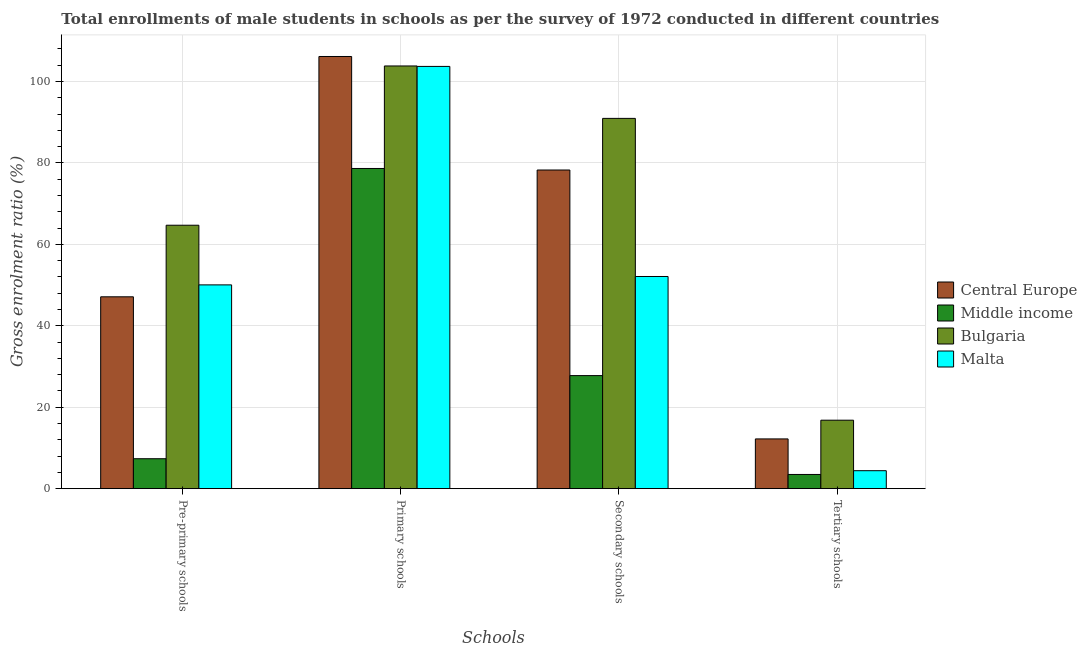How many different coloured bars are there?
Make the answer very short. 4. How many groups of bars are there?
Provide a succinct answer. 4. Are the number of bars on each tick of the X-axis equal?
Provide a succinct answer. Yes. How many bars are there on the 1st tick from the right?
Your response must be concise. 4. What is the label of the 4th group of bars from the left?
Offer a very short reply. Tertiary schools. What is the gross enrolment ratio(male) in secondary schools in Bulgaria?
Ensure brevity in your answer.  90.93. Across all countries, what is the maximum gross enrolment ratio(male) in secondary schools?
Provide a succinct answer. 90.93. Across all countries, what is the minimum gross enrolment ratio(male) in secondary schools?
Offer a terse response. 27.77. In which country was the gross enrolment ratio(male) in secondary schools maximum?
Your response must be concise. Bulgaria. What is the total gross enrolment ratio(male) in tertiary schools in the graph?
Ensure brevity in your answer.  36.94. What is the difference between the gross enrolment ratio(male) in secondary schools in Bulgaria and that in Central Europe?
Your answer should be very brief. 12.68. What is the difference between the gross enrolment ratio(male) in primary schools in Bulgaria and the gross enrolment ratio(male) in pre-primary schools in Middle income?
Give a very brief answer. 96.44. What is the average gross enrolment ratio(male) in primary schools per country?
Provide a short and direct response. 98.06. What is the difference between the gross enrolment ratio(male) in secondary schools and gross enrolment ratio(male) in primary schools in Central Europe?
Offer a very short reply. -27.88. What is the ratio of the gross enrolment ratio(male) in secondary schools in Bulgaria to that in Central Europe?
Give a very brief answer. 1.16. Is the difference between the gross enrolment ratio(male) in tertiary schools in Bulgaria and Central Europe greater than the difference between the gross enrolment ratio(male) in secondary schools in Bulgaria and Central Europe?
Provide a short and direct response. No. What is the difference between the highest and the second highest gross enrolment ratio(male) in pre-primary schools?
Your answer should be very brief. 14.65. What is the difference between the highest and the lowest gross enrolment ratio(male) in pre-primary schools?
Provide a short and direct response. 57.33. In how many countries, is the gross enrolment ratio(male) in tertiary schools greater than the average gross enrolment ratio(male) in tertiary schools taken over all countries?
Make the answer very short. 2. Is the sum of the gross enrolment ratio(male) in secondary schools in Bulgaria and Central Europe greater than the maximum gross enrolment ratio(male) in primary schools across all countries?
Ensure brevity in your answer.  Yes. Is it the case that in every country, the sum of the gross enrolment ratio(male) in pre-primary schools and gross enrolment ratio(male) in secondary schools is greater than the sum of gross enrolment ratio(male) in tertiary schools and gross enrolment ratio(male) in primary schools?
Your answer should be compact. No. What does the 2nd bar from the left in Secondary schools represents?
Provide a succinct answer. Middle income. What does the 4th bar from the right in Secondary schools represents?
Offer a very short reply. Central Europe. Is it the case that in every country, the sum of the gross enrolment ratio(male) in pre-primary schools and gross enrolment ratio(male) in primary schools is greater than the gross enrolment ratio(male) in secondary schools?
Make the answer very short. Yes. Does the graph contain any zero values?
Keep it short and to the point. No. Does the graph contain grids?
Offer a very short reply. Yes. Where does the legend appear in the graph?
Your answer should be compact. Center right. What is the title of the graph?
Your response must be concise. Total enrollments of male students in schools as per the survey of 1972 conducted in different countries. What is the label or title of the X-axis?
Ensure brevity in your answer.  Schools. What is the Gross enrolment ratio (%) of Central Europe in Pre-primary schools?
Offer a very short reply. 47.12. What is the Gross enrolment ratio (%) in Middle income in Pre-primary schools?
Make the answer very short. 7.36. What is the Gross enrolment ratio (%) of Bulgaria in Pre-primary schools?
Offer a terse response. 64.69. What is the Gross enrolment ratio (%) in Malta in Pre-primary schools?
Your answer should be very brief. 50.04. What is the Gross enrolment ratio (%) of Central Europe in Primary schools?
Provide a short and direct response. 106.13. What is the Gross enrolment ratio (%) of Middle income in Primary schools?
Make the answer very short. 78.63. What is the Gross enrolment ratio (%) of Bulgaria in Primary schools?
Your answer should be compact. 103.8. What is the Gross enrolment ratio (%) of Malta in Primary schools?
Ensure brevity in your answer.  103.69. What is the Gross enrolment ratio (%) of Central Europe in Secondary schools?
Keep it short and to the point. 78.25. What is the Gross enrolment ratio (%) of Middle income in Secondary schools?
Your answer should be compact. 27.77. What is the Gross enrolment ratio (%) in Bulgaria in Secondary schools?
Keep it short and to the point. 90.93. What is the Gross enrolment ratio (%) in Malta in Secondary schools?
Provide a short and direct response. 52.1. What is the Gross enrolment ratio (%) in Central Europe in Tertiary schools?
Give a very brief answer. 12.22. What is the Gross enrolment ratio (%) of Middle income in Tertiary schools?
Ensure brevity in your answer.  3.49. What is the Gross enrolment ratio (%) of Bulgaria in Tertiary schools?
Offer a terse response. 16.82. What is the Gross enrolment ratio (%) in Malta in Tertiary schools?
Give a very brief answer. 4.42. Across all Schools, what is the maximum Gross enrolment ratio (%) in Central Europe?
Your response must be concise. 106.13. Across all Schools, what is the maximum Gross enrolment ratio (%) of Middle income?
Your answer should be compact. 78.63. Across all Schools, what is the maximum Gross enrolment ratio (%) in Bulgaria?
Provide a succinct answer. 103.8. Across all Schools, what is the maximum Gross enrolment ratio (%) in Malta?
Your response must be concise. 103.69. Across all Schools, what is the minimum Gross enrolment ratio (%) in Central Europe?
Offer a very short reply. 12.22. Across all Schools, what is the minimum Gross enrolment ratio (%) in Middle income?
Make the answer very short. 3.49. Across all Schools, what is the minimum Gross enrolment ratio (%) of Bulgaria?
Your answer should be compact. 16.82. Across all Schools, what is the minimum Gross enrolment ratio (%) in Malta?
Your response must be concise. 4.42. What is the total Gross enrolment ratio (%) of Central Europe in the graph?
Provide a short and direct response. 243.71. What is the total Gross enrolment ratio (%) in Middle income in the graph?
Provide a succinct answer. 117.24. What is the total Gross enrolment ratio (%) in Bulgaria in the graph?
Your answer should be very brief. 276.23. What is the total Gross enrolment ratio (%) of Malta in the graph?
Provide a succinct answer. 210.25. What is the difference between the Gross enrolment ratio (%) of Central Europe in Pre-primary schools and that in Primary schools?
Make the answer very short. -59.01. What is the difference between the Gross enrolment ratio (%) of Middle income in Pre-primary schools and that in Primary schools?
Offer a very short reply. -71.27. What is the difference between the Gross enrolment ratio (%) of Bulgaria in Pre-primary schools and that in Primary schools?
Provide a short and direct response. -39.11. What is the difference between the Gross enrolment ratio (%) of Malta in Pre-primary schools and that in Primary schools?
Your response must be concise. -53.65. What is the difference between the Gross enrolment ratio (%) of Central Europe in Pre-primary schools and that in Secondary schools?
Offer a very short reply. -31.13. What is the difference between the Gross enrolment ratio (%) in Middle income in Pre-primary schools and that in Secondary schools?
Give a very brief answer. -20.41. What is the difference between the Gross enrolment ratio (%) in Bulgaria in Pre-primary schools and that in Secondary schools?
Offer a very short reply. -26.24. What is the difference between the Gross enrolment ratio (%) of Malta in Pre-primary schools and that in Secondary schools?
Make the answer very short. -2.06. What is the difference between the Gross enrolment ratio (%) in Central Europe in Pre-primary schools and that in Tertiary schools?
Ensure brevity in your answer.  34.9. What is the difference between the Gross enrolment ratio (%) in Middle income in Pre-primary schools and that in Tertiary schools?
Offer a very short reply. 3.87. What is the difference between the Gross enrolment ratio (%) of Bulgaria in Pre-primary schools and that in Tertiary schools?
Your answer should be very brief. 47.87. What is the difference between the Gross enrolment ratio (%) of Malta in Pre-primary schools and that in Tertiary schools?
Your response must be concise. 45.63. What is the difference between the Gross enrolment ratio (%) in Central Europe in Primary schools and that in Secondary schools?
Offer a very short reply. 27.88. What is the difference between the Gross enrolment ratio (%) of Middle income in Primary schools and that in Secondary schools?
Provide a succinct answer. 50.86. What is the difference between the Gross enrolment ratio (%) of Bulgaria in Primary schools and that in Secondary schools?
Your answer should be very brief. 12.87. What is the difference between the Gross enrolment ratio (%) of Malta in Primary schools and that in Secondary schools?
Ensure brevity in your answer.  51.58. What is the difference between the Gross enrolment ratio (%) of Central Europe in Primary schools and that in Tertiary schools?
Provide a succinct answer. 93.91. What is the difference between the Gross enrolment ratio (%) in Middle income in Primary schools and that in Tertiary schools?
Your response must be concise. 75.14. What is the difference between the Gross enrolment ratio (%) of Bulgaria in Primary schools and that in Tertiary schools?
Make the answer very short. 86.98. What is the difference between the Gross enrolment ratio (%) of Malta in Primary schools and that in Tertiary schools?
Provide a succinct answer. 99.27. What is the difference between the Gross enrolment ratio (%) in Central Europe in Secondary schools and that in Tertiary schools?
Provide a succinct answer. 66.03. What is the difference between the Gross enrolment ratio (%) of Middle income in Secondary schools and that in Tertiary schools?
Ensure brevity in your answer.  24.28. What is the difference between the Gross enrolment ratio (%) in Bulgaria in Secondary schools and that in Tertiary schools?
Your response must be concise. 74.11. What is the difference between the Gross enrolment ratio (%) in Malta in Secondary schools and that in Tertiary schools?
Offer a terse response. 47.69. What is the difference between the Gross enrolment ratio (%) of Central Europe in Pre-primary schools and the Gross enrolment ratio (%) of Middle income in Primary schools?
Give a very brief answer. -31.51. What is the difference between the Gross enrolment ratio (%) in Central Europe in Pre-primary schools and the Gross enrolment ratio (%) in Bulgaria in Primary schools?
Offer a terse response. -56.68. What is the difference between the Gross enrolment ratio (%) of Central Europe in Pre-primary schools and the Gross enrolment ratio (%) of Malta in Primary schools?
Your answer should be very brief. -56.57. What is the difference between the Gross enrolment ratio (%) in Middle income in Pre-primary schools and the Gross enrolment ratio (%) in Bulgaria in Primary schools?
Make the answer very short. -96.44. What is the difference between the Gross enrolment ratio (%) in Middle income in Pre-primary schools and the Gross enrolment ratio (%) in Malta in Primary schools?
Keep it short and to the point. -96.33. What is the difference between the Gross enrolment ratio (%) of Bulgaria in Pre-primary schools and the Gross enrolment ratio (%) of Malta in Primary schools?
Make the answer very short. -39. What is the difference between the Gross enrolment ratio (%) of Central Europe in Pre-primary schools and the Gross enrolment ratio (%) of Middle income in Secondary schools?
Your answer should be compact. 19.35. What is the difference between the Gross enrolment ratio (%) in Central Europe in Pre-primary schools and the Gross enrolment ratio (%) in Bulgaria in Secondary schools?
Keep it short and to the point. -43.81. What is the difference between the Gross enrolment ratio (%) in Central Europe in Pre-primary schools and the Gross enrolment ratio (%) in Malta in Secondary schools?
Give a very brief answer. -4.99. What is the difference between the Gross enrolment ratio (%) of Middle income in Pre-primary schools and the Gross enrolment ratio (%) of Bulgaria in Secondary schools?
Offer a terse response. -83.57. What is the difference between the Gross enrolment ratio (%) of Middle income in Pre-primary schools and the Gross enrolment ratio (%) of Malta in Secondary schools?
Give a very brief answer. -44.75. What is the difference between the Gross enrolment ratio (%) of Bulgaria in Pre-primary schools and the Gross enrolment ratio (%) of Malta in Secondary schools?
Provide a short and direct response. 12.59. What is the difference between the Gross enrolment ratio (%) of Central Europe in Pre-primary schools and the Gross enrolment ratio (%) of Middle income in Tertiary schools?
Offer a terse response. 43.63. What is the difference between the Gross enrolment ratio (%) in Central Europe in Pre-primary schools and the Gross enrolment ratio (%) in Bulgaria in Tertiary schools?
Offer a very short reply. 30.3. What is the difference between the Gross enrolment ratio (%) of Central Europe in Pre-primary schools and the Gross enrolment ratio (%) of Malta in Tertiary schools?
Ensure brevity in your answer.  42.7. What is the difference between the Gross enrolment ratio (%) in Middle income in Pre-primary schools and the Gross enrolment ratio (%) in Bulgaria in Tertiary schools?
Your response must be concise. -9.46. What is the difference between the Gross enrolment ratio (%) of Middle income in Pre-primary schools and the Gross enrolment ratio (%) of Malta in Tertiary schools?
Offer a very short reply. 2.94. What is the difference between the Gross enrolment ratio (%) in Bulgaria in Pre-primary schools and the Gross enrolment ratio (%) in Malta in Tertiary schools?
Offer a terse response. 60.27. What is the difference between the Gross enrolment ratio (%) of Central Europe in Primary schools and the Gross enrolment ratio (%) of Middle income in Secondary schools?
Give a very brief answer. 78.36. What is the difference between the Gross enrolment ratio (%) of Central Europe in Primary schools and the Gross enrolment ratio (%) of Bulgaria in Secondary schools?
Your response must be concise. 15.2. What is the difference between the Gross enrolment ratio (%) of Central Europe in Primary schools and the Gross enrolment ratio (%) of Malta in Secondary schools?
Keep it short and to the point. 54.02. What is the difference between the Gross enrolment ratio (%) of Middle income in Primary schools and the Gross enrolment ratio (%) of Bulgaria in Secondary schools?
Make the answer very short. -12.3. What is the difference between the Gross enrolment ratio (%) of Middle income in Primary schools and the Gross enrolment ratio (%) of Malta in Secondary schools?
Give a very brief answer. 26.52. What is the difference between the Gross enrolment ratio (%) in Bulgaria in Primary schools and the Gross enrolment ratio (%) in Malta in Secondary schools?
Ensure brevity in your answer.  51.69. What is the difference between the Gross enrolment ratio (%) in Central Europe in Primary schools and the Gross enrolment ratio (%) in Middle income in Tertiary schools?
Your response must be concise. 102.64. What is the difference between the Gross enrolment ratio (%) of Central Europe in Primary schools and the Gross enrolment ratio (%) of Bulgaria in Tertiary schools?
Your answer should be very brief. 89.31. What is the difference between the Gross enrolment ratio (%) of Central Europe in Primary schools and the Gross enrolment ratio (%) of Malta in Tertiary schools?
Provide a succinct answer. 101.71. What is the difference between the Gross enrolment ratio (%) of Middle income in Primary schools and the Gross enrolment ratio (%) of Bulgaria in Tertiary schools?
Keep it short and to the point. 61.81. What is the difference between the Gross enrolment ratio (%) of Middle income in Primary schools and the Gross enrolment ratio (%) of Malta in Tertiary schools?
Your answer should be compact. 74.21. What is the difference between the Gross enrolment ratio (%) of Bulgaria in Primary schools and the Gross enrolment ratio (%) of Malta in Tertiary schools?
Provide a succinct answer. 99.38. What is the difference between the Gross enrolment ratio (%) of Central Europe in Secondary schools and the Gross enrolment ratio (%) of Middle income in Tertiary schools?
Provide a short and direct response. 74.76. What is the difference between the Gross enrolment ratio (%) in Central Europe in Secondary schools and the Gross enrolment ratio (%) in Bulgaria in Tertiary schools?
Your answer should be compact. 61.43. What is the difference between the Gross enrolment ratio (%) of Central Europe in Secondary schools and the Gross enrolment ratio (%) of Malta in Tertiary schools?
Offer a very short reply. 73.83. What is the difference between the Gross enrolment ratio (%) of Middle income in Secondary schools and the Gross enrolment ratio (%) of Bulgaria in Tertiary schools?
Offer a very short reply. 10.95. What is the difference between the Gross enrolment ratio (%) of Middle income in Secondary schools and the Gross enrolment ratio (%) of Malta in Tertiary schools?
Offer a terse response. 23.35. What is the difference between the Gross enrolment ratio (%) of Bulgaria in Secondary schools and the Gross enrolment ratio (%) of Malta in Tertiary schools?
Your response must be concise. 86.51. What is the average Gross enrolment ratio (%) of Central Europe per Schools?
Provide a short and direct response. 60.93. What is the average Gross enrolment ratio (%) of Middle income per Schools?
Give a very brief answer. 29.31. What is the average Gross enrolment ratio (%) in Bulgaria per Schools?
Your response must be concise. 69.06. What is the average Gross enrolment ratio (%) in Malta per Schools?
Offer a terse response. 52.56. What is the difference between the Gross enrolment ratio (%) of Central Europe and Gross enrolment ratio (%) of Middle income in Pre-primary schools?
Your answer should be very brief. 39.76. What is the difference between the Gross enrolment ratio (%) in Central Europe and Gross enrolment ratio (%) in Bulgaria in Pre-primary schools?
Your response must be concise. -17.57. What is the difference between the Gross enrolment ratio (%) in Central Europe and Gross enrolment ratio (%) in Malta in Pre-primary schools?
Provide a succinct answer. -2.93. What is the difference between the Gross enrolment ratio (%) of Middle income and Gross enrolment ratio (%) of Bulgaria in Pre-primary schools?
Your answer should be very brief. -57.33. What is the difference between the Gross enrolment ratio (%) in Middle income and Gross enrolment ratio (%) in Malta in Pre-primary schools?
Give a very brief answer. -42.69. What is the difference between the Gross enrolment ratio (%) of Bulgaria and Gross enrolment ratio (%) of Malta in Pre-primary schools?
Offer a terse response. 14.65. What is the difference between the Gross enrolment ratio (%) of Central Europe and Gross enrolment ratio (%) of Middle income in Primary schools?
Make the answer very short. 27.5. What is the difference between the Gross enrolment ratio (%) of Central Europe and Gross enrolment ratio (%) of Bulgaria in Primary schools?
Provide a succinct answer. 2.33. What is the difference between the Gross enrolment ratio (%) in Central Europe and Gross enrolment ratio (%) in Malta in Primary schools?
Your answer should be compact. 2.44. What is the difference between the Gross enrolment ratio (%) of Middle income and Gross enrolment ratio (%) of Bulgaria in Primary schools?
Make the answer very short. -25.17. What is the difference between the Gross enrolment ratio (%) in Middle income and Gross enrolment ratio (%) in Malta in Primary schools?
Offer a terse response. -25.06. What is the difference between the Gross enrolment ratio (%) in Bulgaria and Gross enrolment ratio (%) in Malta in Primary schools?
Keep it short and to the point. 0.11. What is the difference between the Gross enrolment ratio (%) of Central Europe and Gross enrolment ratio (%) of Middle income in Secondary schools?
Give a very brief answer. 50.48. What is the difference between the Gross enrolment ratio (%) in Central Europe and Gross enrolment ratio (%) in Bulgaria in Secondary schools?
Your answer should be very brief. -12.68. What is the difference between the Gross enrolment ratio (%) of Central Europe and Gross enrolment ratio (%) of Malta in Secondary schools?
Your answer should be very brief. 26.15. What is the difference between the Gross enrolment ratio (%) of Middle income and Gross enrolment ratio (%) of Bulgaria in Secondary schools?
Make the answer very short. -63.16. What is the difference between the Gross enrolment ratio (%) of Middle income and Gross enrolment ratio (%) of Malta in Secondary schools?
Provide a short and direct response. -24.34. What is the difference between the Gross enrolment ratio (%) in Bulgaria and Gross enrolment ratio (%) in Malta in Secondary schools?
Make the answer very short. 38.82. What is the difference between the Gross enrolment ratio (%) in Central Europe and Gross enrolment ratio (%) in Middle income in Tertiary schools?
Ensure brevity in your answer.  8.73. What is the difference between the Gross enrolment ratio (%) in Central Europe and Gross enrolment ratio (%) in Bulgaria in Tertiary schools?
Offer a terse response. -4.6. What is the difference between the Gross enrolment ratio (%) in Central Europe and Gross enrolment ratio (%) in Malta in Tertiary schools?
Give a very brief answer. 7.8. What is the difference between the Gross enrolment ratio (%) in Middle income and Gross enrolment ratio (%) in Bulgaria in Tertiary schools?
Give a very brief answer. -13.33. What is the difference between the Gross enrolment ratio (%) in Middle income and Gross enrolment ratio (%) in Malta in Tertiary schools?
Your answer should be very brief. -0.93. What is the difference between the Gross enrolment ratio (%) of Bulgaria and Gross enrolment ratio (%) of Malta in Tertiary schools?
Make the answer very short. 12.4. What is the ratio of the Gross enrolment ratio (%) of Central Europe in Pre-primary schools to that in Primary schools?
Provide a short and direct response. 0.44. What is the ratio of the Gross enrolment ratio (%) of Middle income in Pre-primary schools to that in Primary schools?
Provide a succinct answer. 0.09. What is the ratio of the Gross enrolment ratio (%) in Bulgaria in Pre-primary schools to that in Primary schools?
Your answer should be very brief. 0.62. What is the ratio of the Gross enrolment ratio (%) in Malta in Pre-primary schools to that in Primary schools?
Keep it short and to the point. 0.48. What is the ratio of the Gross enrolment ratio (%) in Central Europe in Pre-primary schools to that in Secondary schools?
Your response must be concise. 0.6. What is the ratio of the Gross enrolment ratio (%) of Middle income in Pre-primary schools to that in Secondary schools?
Make the answer very short. 0.26. What is the ratio of the Gross enrolment ratio (%) in Bulgaria in Pre-primary schools to that in Secondary schools?
Ensure brevity in your answer.  0.71. What is the ratio of the Gross enrolment ratio (%) in Malta in Pre-primary schools to that in Secondary schools?
Make the answer very short. 0.96. What is the ratio of the Gross enrolment ratio (%) in Central Europe in Pre-primary schools to that in Tertiary schools?
Your answer should be very brief. 3.86. What is the ratio of the Gross enrolment ratio (%) of Middle income in Pre-primary schools to that in Tertiary schools?
Make the answer very short. 2.11. What is the ratio of the Gross enrolment ratio (%) in Bulgaria in Pre-primary schools to that in Tertiary schools?
Give a very brief answer. 3.85. What is the ratio of the Gross enrolment ratio (%) of Malta in Pre-primary schools to that in Tertiary schools?
Your response must be concise. 11.33. What is the ratio of the Gross enrolment ratio (%) in Central Europe in Primary schools to that in Secondary schools?
Provide a succinct answer. 1.36. What is the ratio of the Gross enrolment ratio (%) in Middle income in Primary schools to that in Secondary schools?
Ensure brevity in your answer.  2.83. What is the ratio of the Gross enrolment ratio (%) in Bulgaria in Primary schools to that in Secondary schools?
Give a very brief answer. 1.14. What is the ratio of the Gross enrolment ratio (%) of Malta in Primary schools to that in Secondary schools?
Keep it short and to the point. 1.99. What is the ratio of the Gross enrolment ratio (%) of Central Europe in Primary schools to that in Tertiary schools?
Keep it short and to the point. 8.69. What is the ratio of the Gross enrolment ratio (%) of Middle income in Primary schools to that in Tertiary schools?
Your response must be concise. 22.54. What is the ratio of the Gross enrolment ratio (%) of Bulgaria in Primary schools to that in Tertiary schools?
Keep it short and to the point. 6.17. What is the ratio of the Gross enrolment ratio (%) in Malta in Primary schools to that in Tertiary schools?
Offer a very short reply. 23.48. What is the ratio of the Gross enrolment ratio (%) of Central Europe in Secondary schools to that in Tertiary schools?
Keep it short and to the point. 6.4. What is the ratio of the Gross enrolment ratio (%) in Middle income in Secondary schools to that in Tertiary schools?
Make the answer very short. 7.96. What is the ratio of the Gross enrolment ratio (%) in Bulgaria in Secondary schools to that in Tertiary schools?
Give a very brief answer. 5.41. What is the ratio of the Gross enrolment ratio (%) of Malta in Secondary schools to that in Tertiary schools?
Your answer should be very brief. 11.8. What is the difference between the highest and the second highest Gross enrolment ratio (%) of Central Europe?
Your answer should be compact. 27.88. What is the difference between the highest and the second highest Gross enrolment ratio (%) in Middle income?
Ensure brevity in your answer.  50.86. What is the difference between the highest and the second highest Gross enrolment ratio (%) in Bulgaria?
Provide a succinct answer. 12.87. What is the difference between the highest and the second highest Gross enrolment ratio (%) of Malta?
Make the answer very short. 51.58. What is the difference between the highest and the lowest Gross enrolment ratio (%) in Central Europe?
Provide a succinct answer. 93.91. What is the difference between the highest and the lowest Gross enrolment ratio (%) of Middle income?
Your answer should be very brief. 75.14. What is the difference between the highest and the lowest Gross enrolment ratio (%) in Bulgaria?
Your response must be concise. 86.98. What is the difference between the highest and the lowest Gross enrolment ratio (%) of Malta?
Provide a succinct answer. 99.27. 